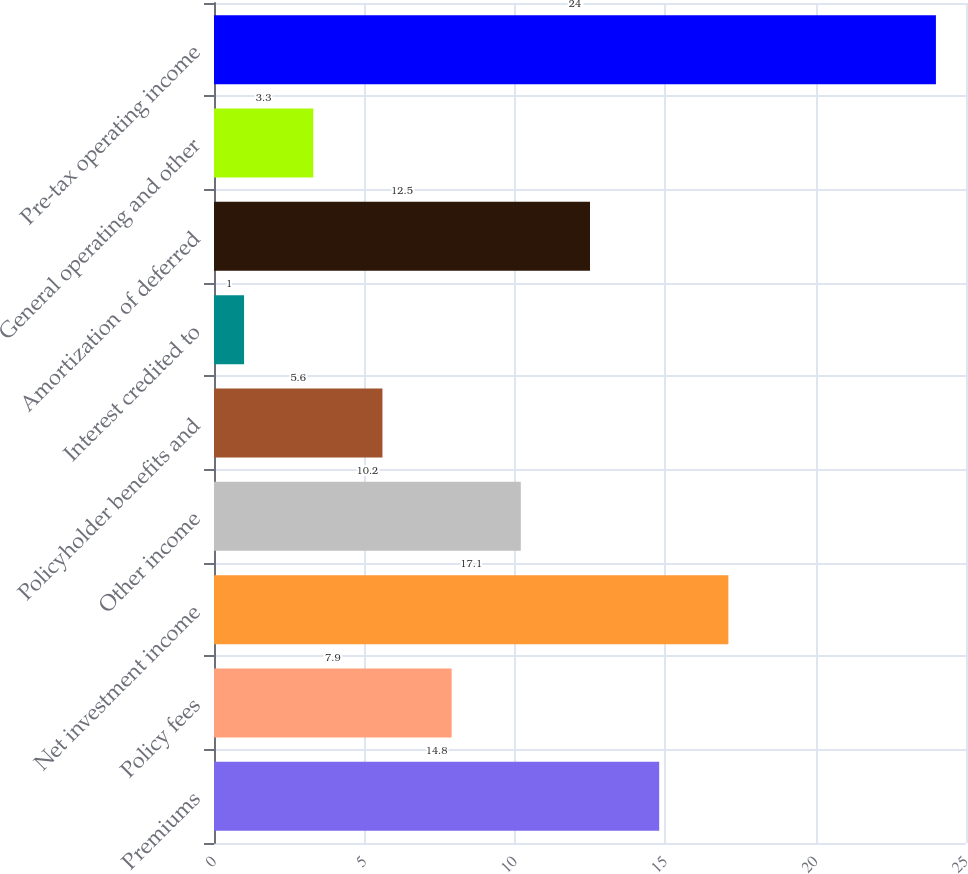Convert chart to OTSL. <chart><loc_0><loc_0><loc_500><loc_500><bar_chart><fcel>Premiums<fcel>Policy fees<fcel>Net investment income<fcel>Other income<fcel>Policyholder benefits and<fcel>Interest credited to<fcel>Amortization of deferred<fcel>General operating and other<fcel>Pre-tax operating income<nl><fcel>14.8<fcel>7.9<fcel>17.1<fcel>10.2<fcel>5.6<fcel>1<fcel>12.5<fcel>3.3<fcel>24<nl></chart> 